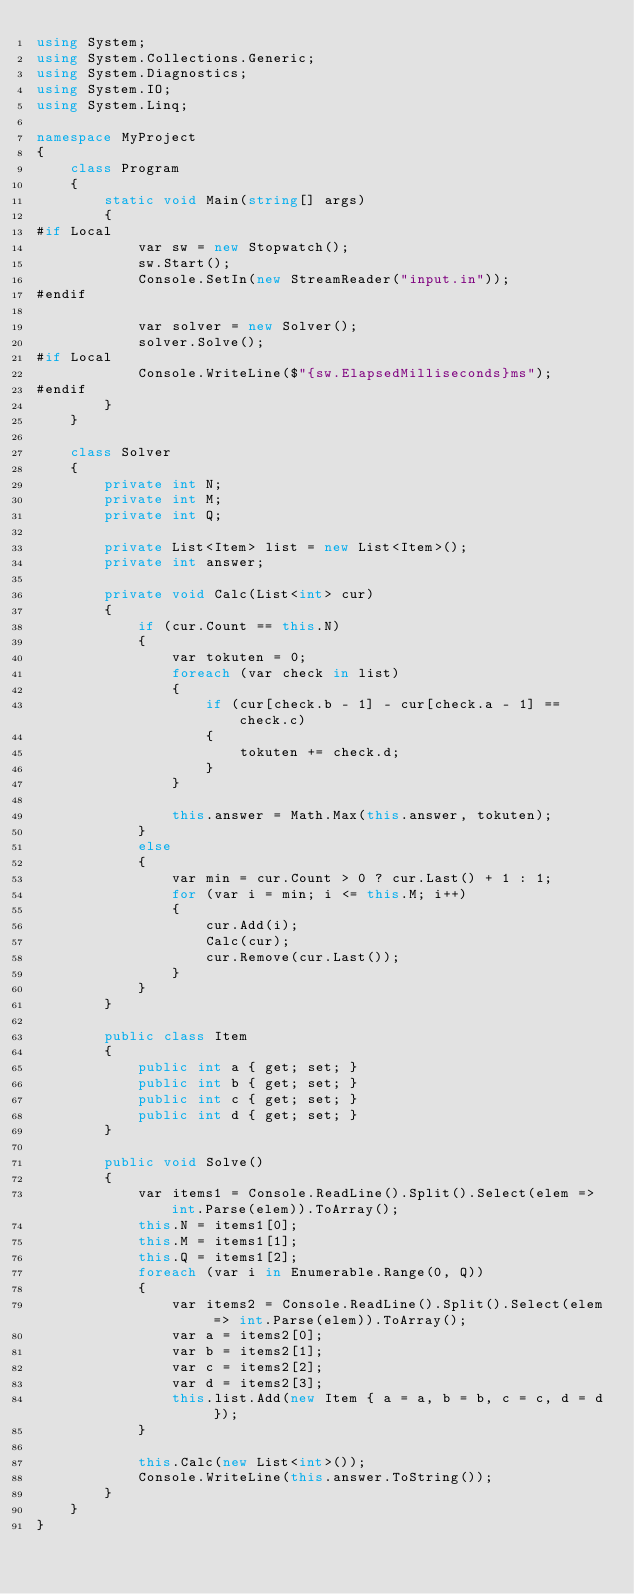<code> <loc_0><loc_0><loc_500><loc_500><_C#_>using System;
using System.Collections.Generic;
using System.Diagnostics;
using System.IO;
using System.Linq;

namespace MyProject
{
    class Program
    {
        static void Main(string[] args)
        {
#if Local
            var sw = new Stopwatch();
            sw.Start();
            Console.SetIn(new StreamReader("input.in"));
#endif

            var solver = new Solver();
            solver.Solve();
#if Local
            Console.WriteLine($"{sw.ElapsedMilliseconds}ms");
#endif
        }
    }

    class Solver
    {
        private int N;
        private int M;
        private int Q;

        private List<Item> list = new List<Item>();
        private int answer;

        private void Calc(List<int> cur)
        {
            if (cur.Count == this.N)
            {
                var tokuten = 0;
                foreach (var check in list)
                {
                    if (cur[check.b - 1] - cur[check.a - 1] == check.c)
                    {
                        tokuten += check.d;
                    }
                }

                this.answer = Math.Max(this.answer, tokuten);
            }
            else
            {
                var min = cur.Count > 0 ? cur.Last() + 1 : 1;
                for (var i = min; i <= this.M; i++)
                {
                    cur.Add(i);
                    Calc(cur);
                    cur.Remove(cur.Last());
                }
            }
        }

        public class Item
        {
            public int a { get; set; }
            public int b { get; set; }
            public int c { get; set; }
            public int d { get; set; }
        }

        public void Solve()
        {
            var items1 = Console.ReadLine().Split().Select(elem => int.Parse(elem)).ToArray();
            this.N = items1[0];
            this.M = items1[1];
            this.Q = items1[2];
            foreach (var i in Enumerable.Range(0, Q))
            {
                var items2 = Console.ReadLine().Split().Select(elem => int.Parse(elem)).ToArray();
                var a = items2[0];
                var b = items2[1];
                var c = items2[2];
                var d = items2[3];
                this.list.Add(new Item { a = a, b = b, c = c, d = d });
            }

            this.Calc(new List<int>());
            Console.WriteLine(this.answer.ToString());
        }
    }
}
</code> 